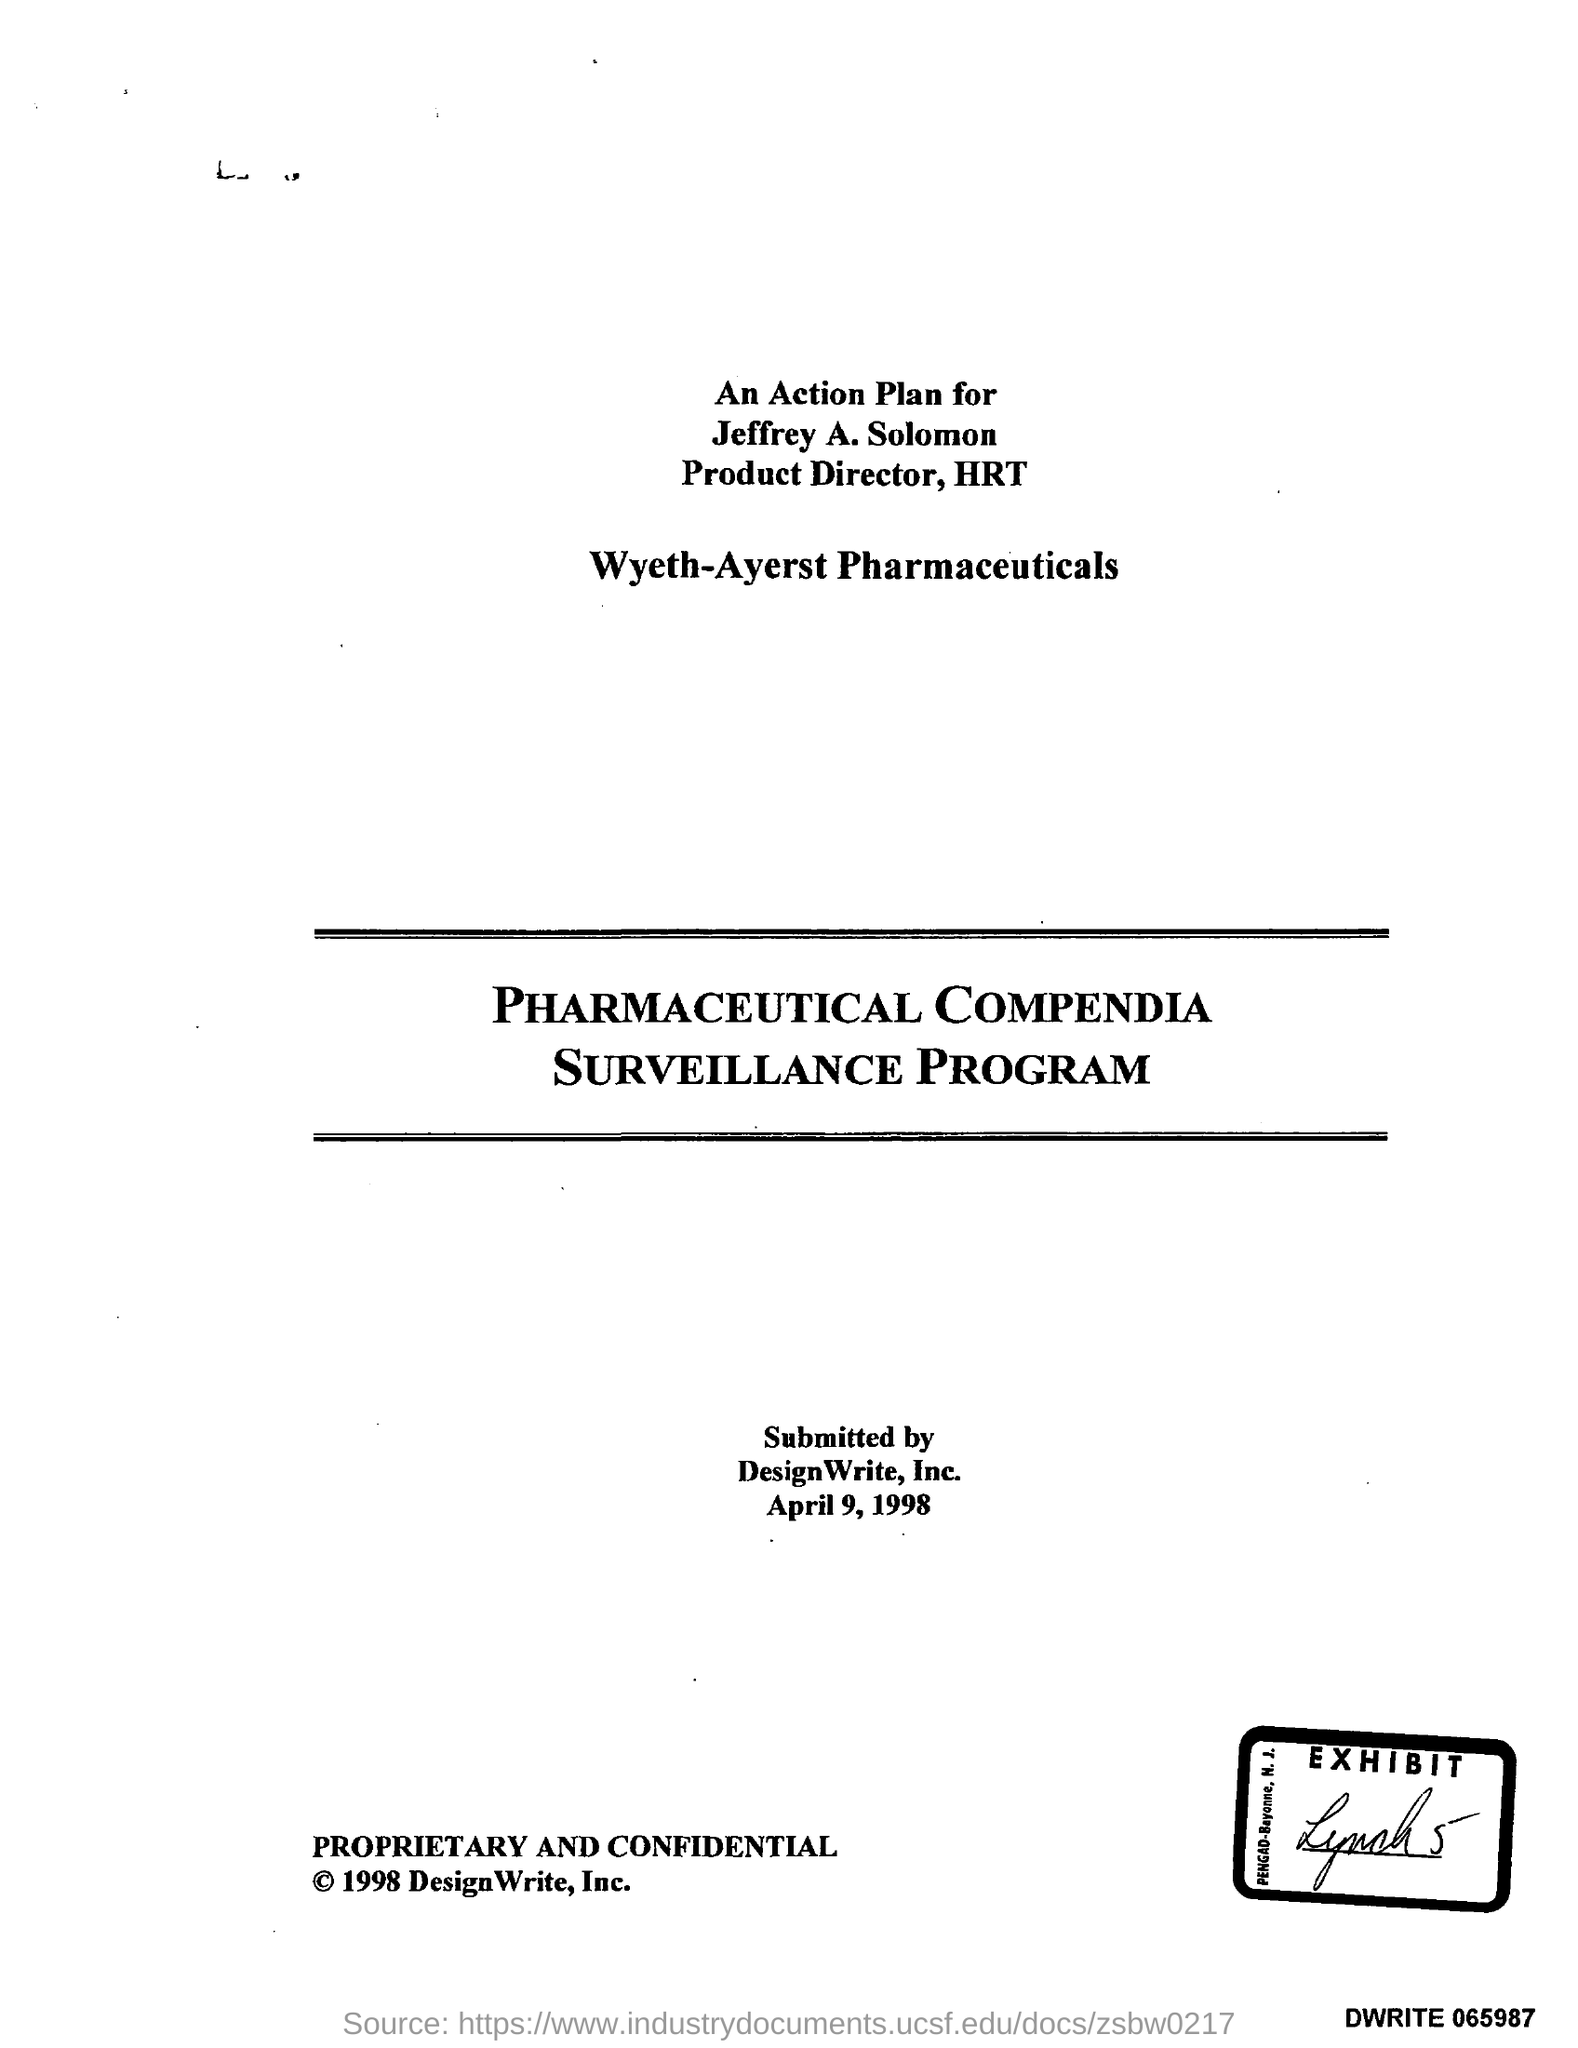Who is the Product Director of HRT?
Give a very brief answer. Jeffrey a. solomon. What is the date mentioned in the document?
Offer a very short reply. April 9,1998. 